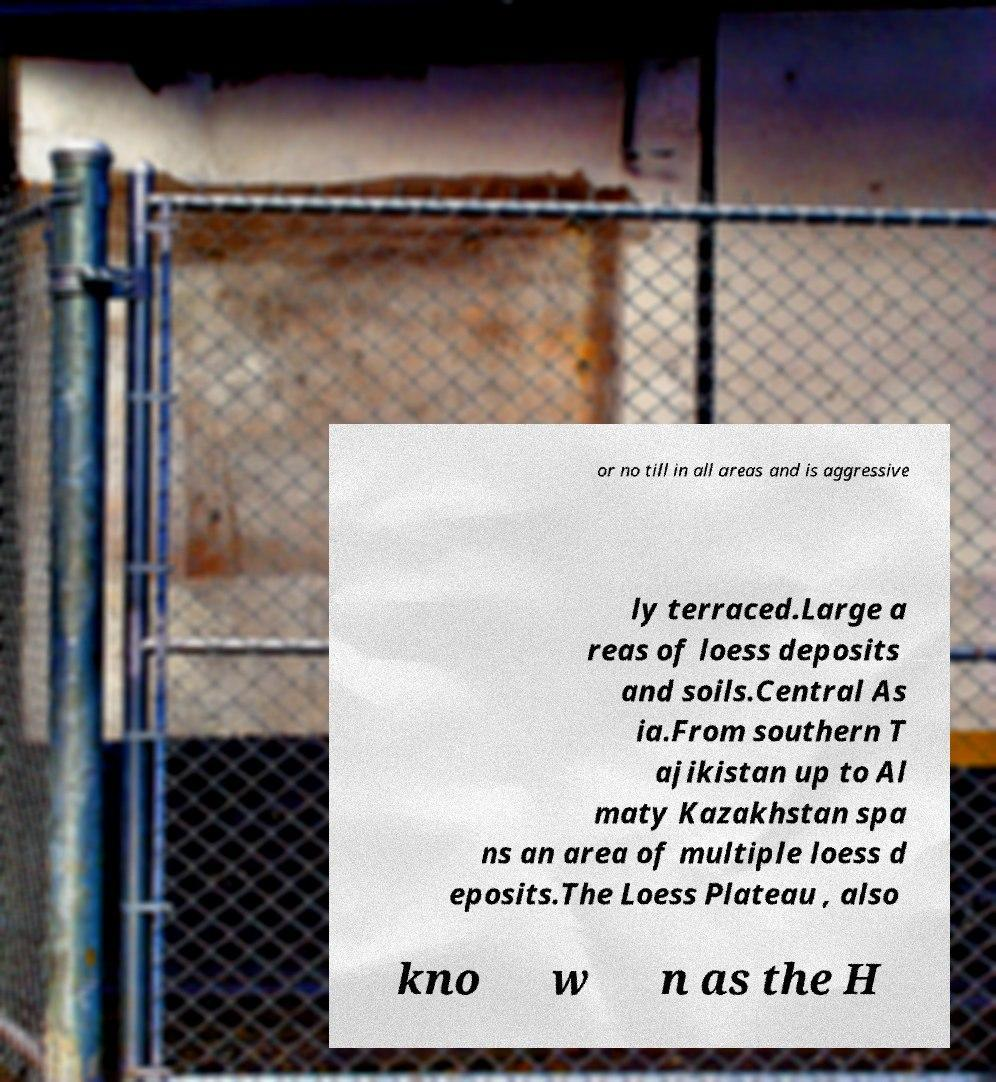Please identify and transcribe the text found in this image. or no till in all areas and is aggressive ly terraced.Large a reas of loess deposits and soils.Central As ia.From southern T ajikistan up to Al maty Kazakhstan spa ns an area of multiple loess d eposits.The Loess Plateau , also kno w n as the H 